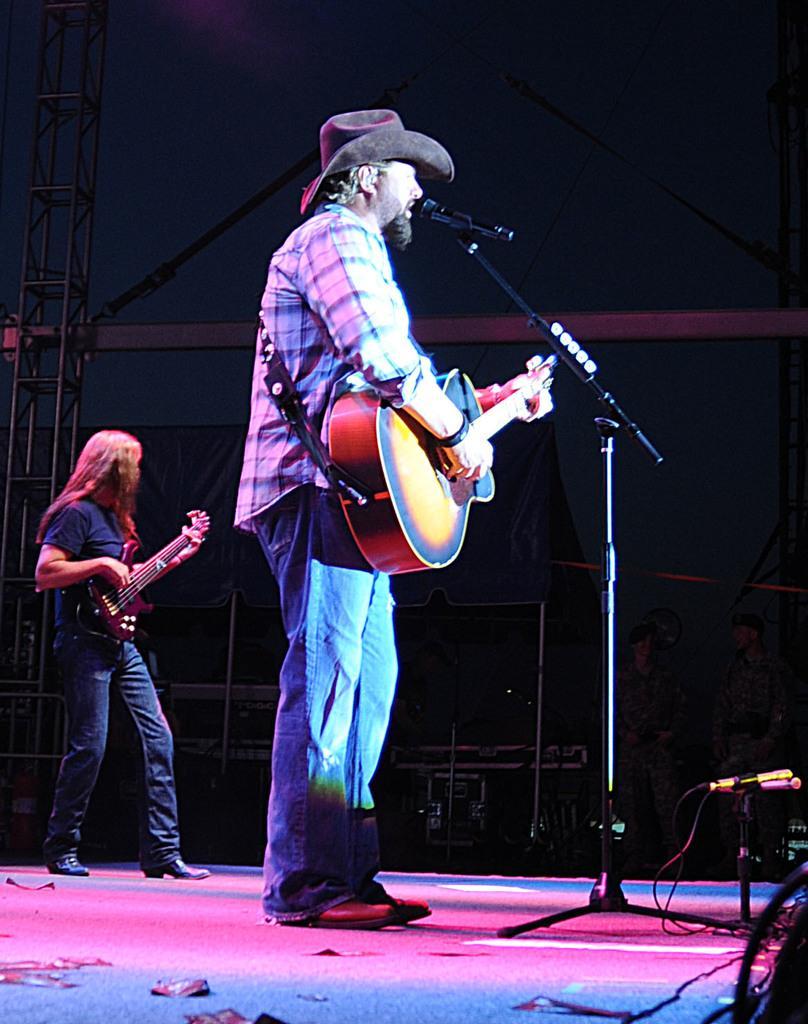Can you describe this image briefly? Here we can see that a person is standing on the floor, and holding guitar in his hands and singing, here is the microphone and stand, and at side here a person is standing and playing guitar. 